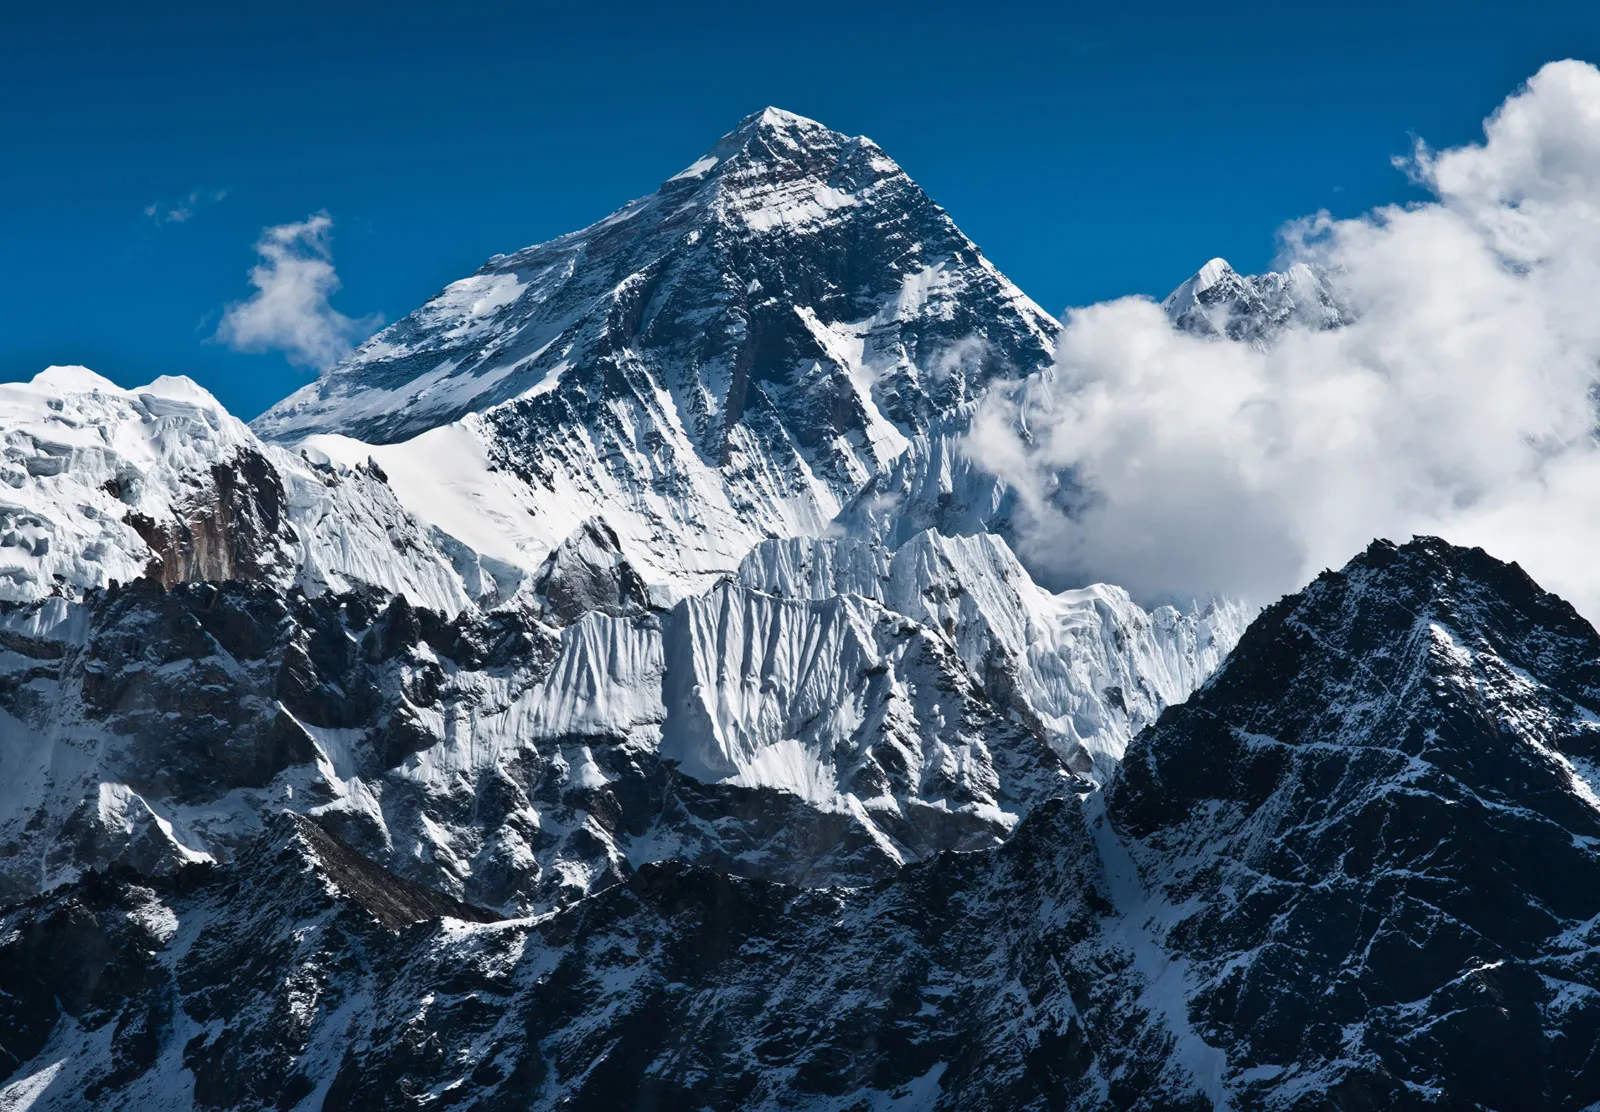What if Mount Everest were actually a colossal, dormant giant covered in snow? Imagine if Mount Everest were actually a colossal, dormant giant, its massive form lying still under a thick blanket of snow. This ancient titan sleeps peacefully, its icy breath forming the glaciers that cascade down its slopes, and its eyes cloaked by endless winters. Legends speak of the day when the giant might awake, shaking off eons of slumber. The shifting of its immense body would reshape the land itself, triggering avalanches and sending reverberations across the Himalayas. This mythical creature's dreams influence the weather, bringing harsh blizzards or serene, clear skies to the region. Local inhabitants revere the giant, offering tributes and songs to keep it tranquil, ever mindful of the delicate balance between its restful peace and potential wrath. 